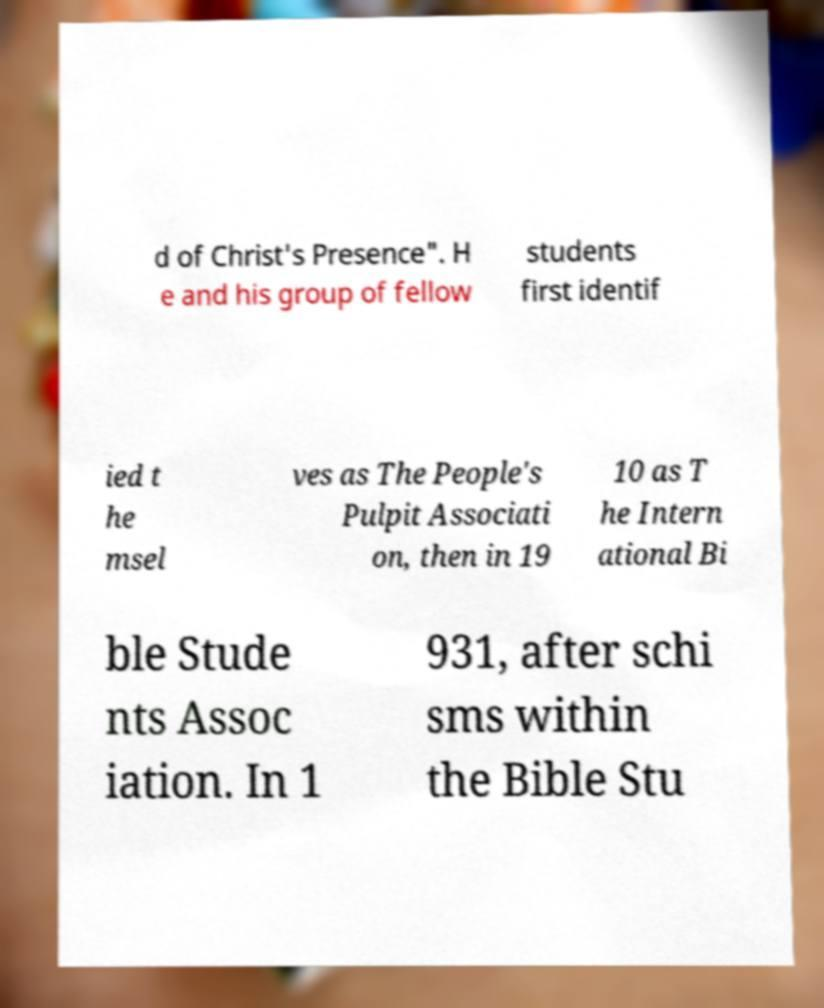Please read and relay the text visible in this image. What does it say? d of Christ's Presence". H e and his group of fellow students first identif ied t he msel ves as The People's Pulpit Associati on, then in 19 10 as T he Intern ational Bi ble Stude nts Assoc iation. In 1 931, after schi sms within the Bible Stu 